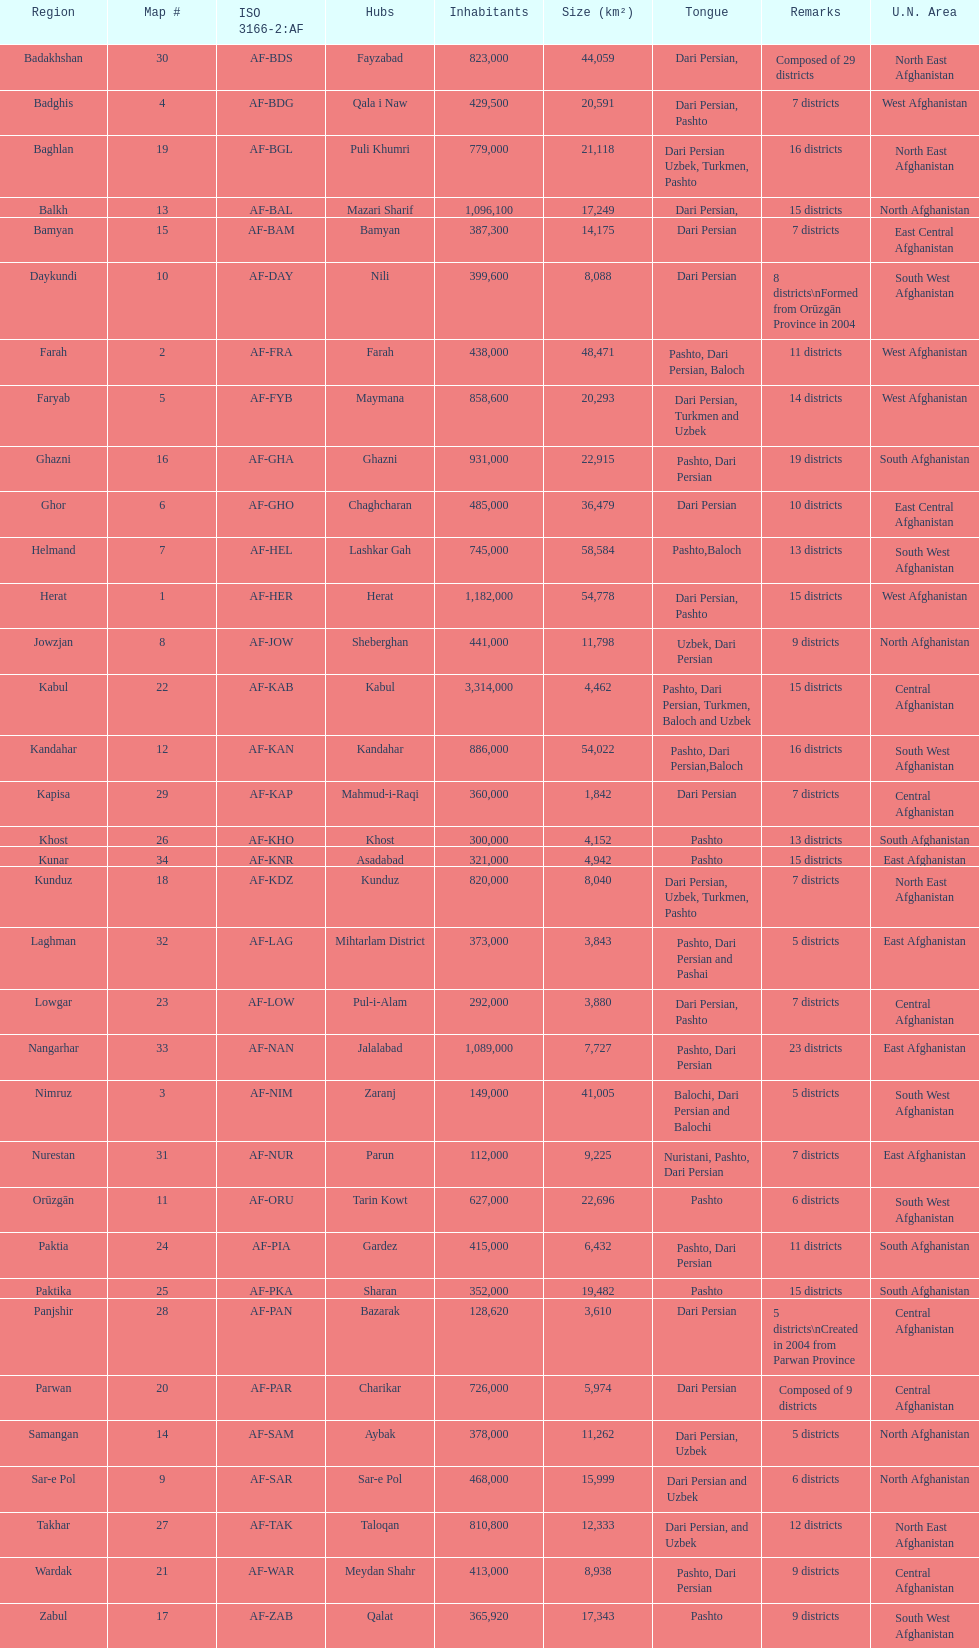In which province is the population the lowest? Nurestan. 